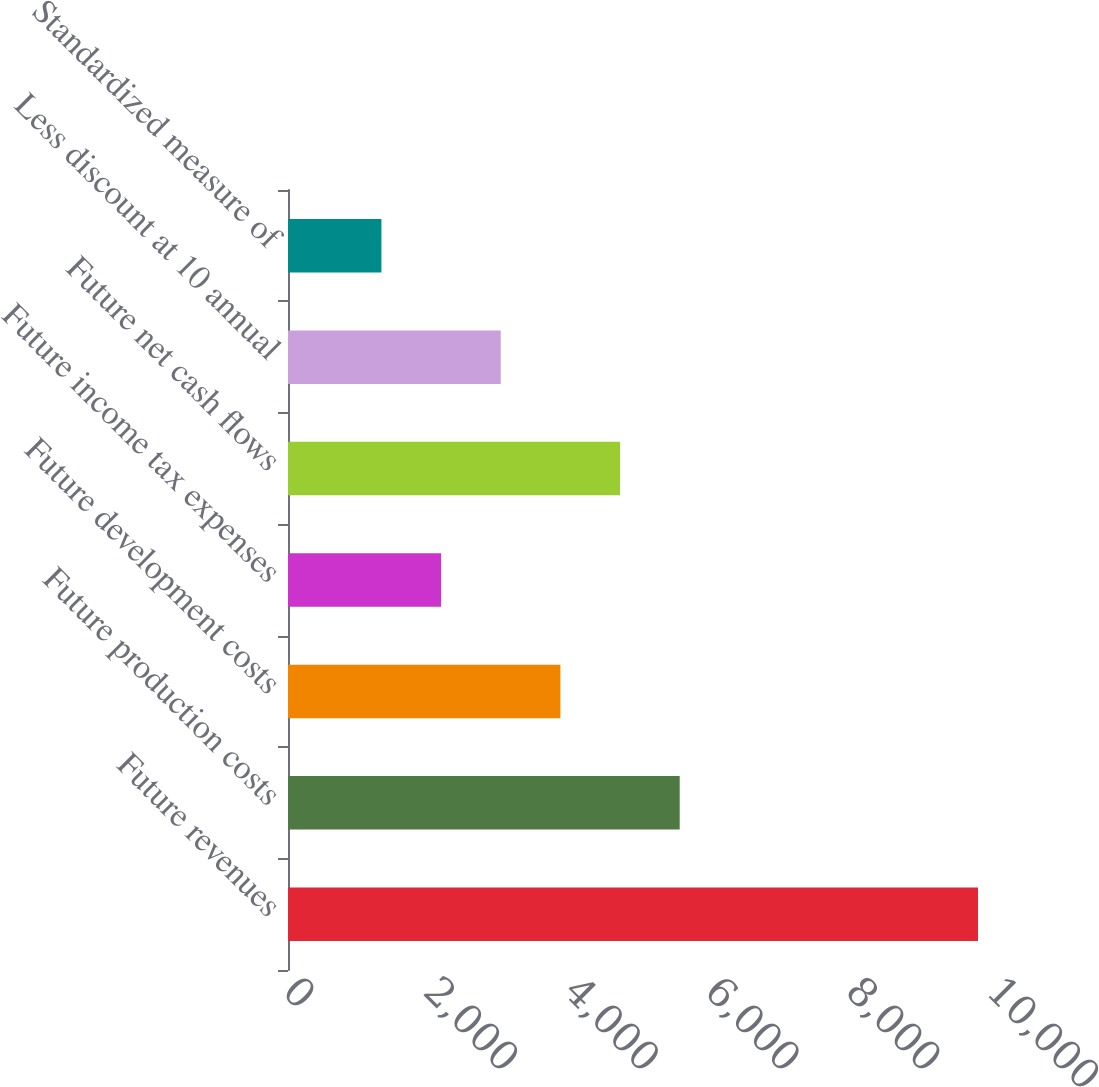<chart> <loc_0><loc_0><loc_500><loc_500><bar_chart><fcel>Future revenues<fcel>Future production costs<fcel>Future development costs<fcel>Future income tax expenses<fcel>Future net cash flows<fcel>Less discount at 10 annual<fcel>Standardized measure of<nl><fcel>9801<fcel>5564<fcel>3869.2<fcel>2174.4<fcel>4716.6<fcel>3021.8<fcel>1327<nl></chart> 